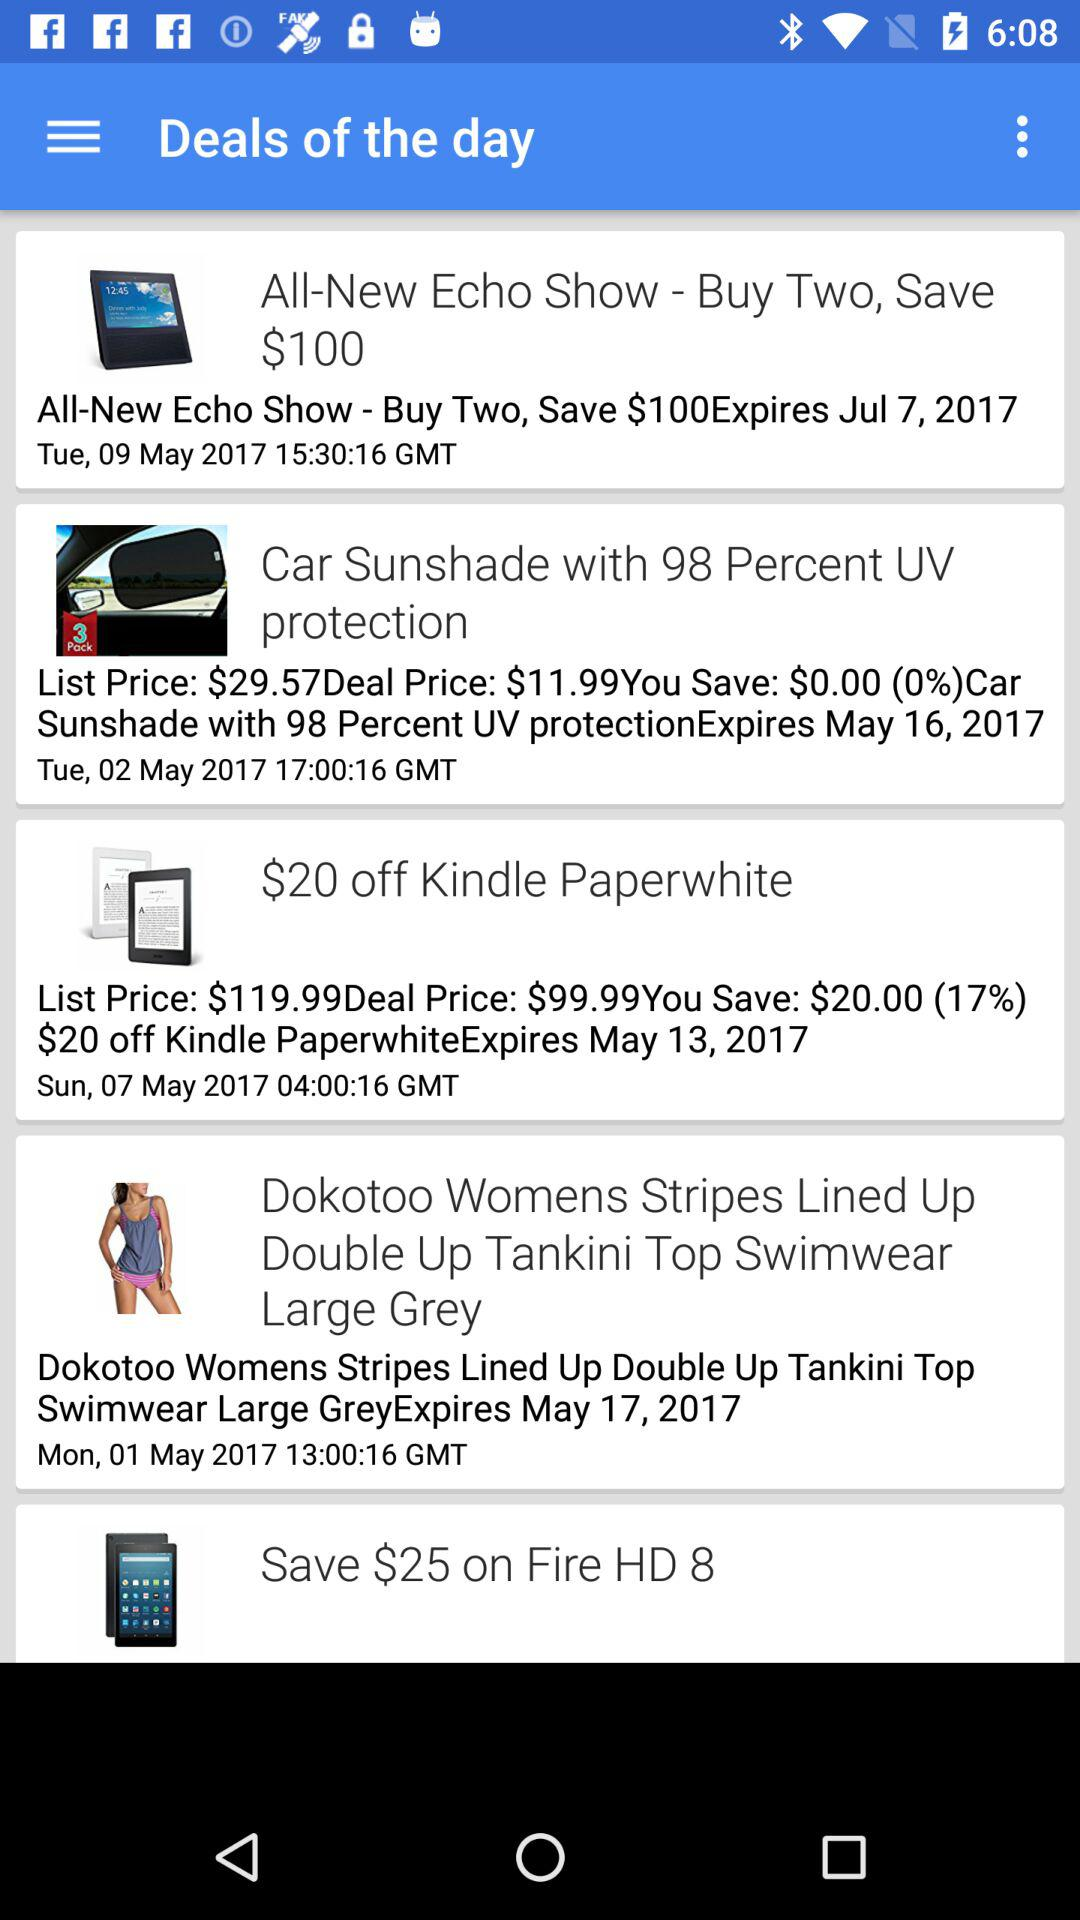At what time was "Car Sunshade with 98 Percent UV protection" posted? "Car Sunshade with 98 Percent UV protection" was posted at 17:00:16 in Greenwich Mean Time. 